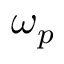<formula> <loc_0><loc_0><loc_500><loc_500>\omega _ { p }</formula> 